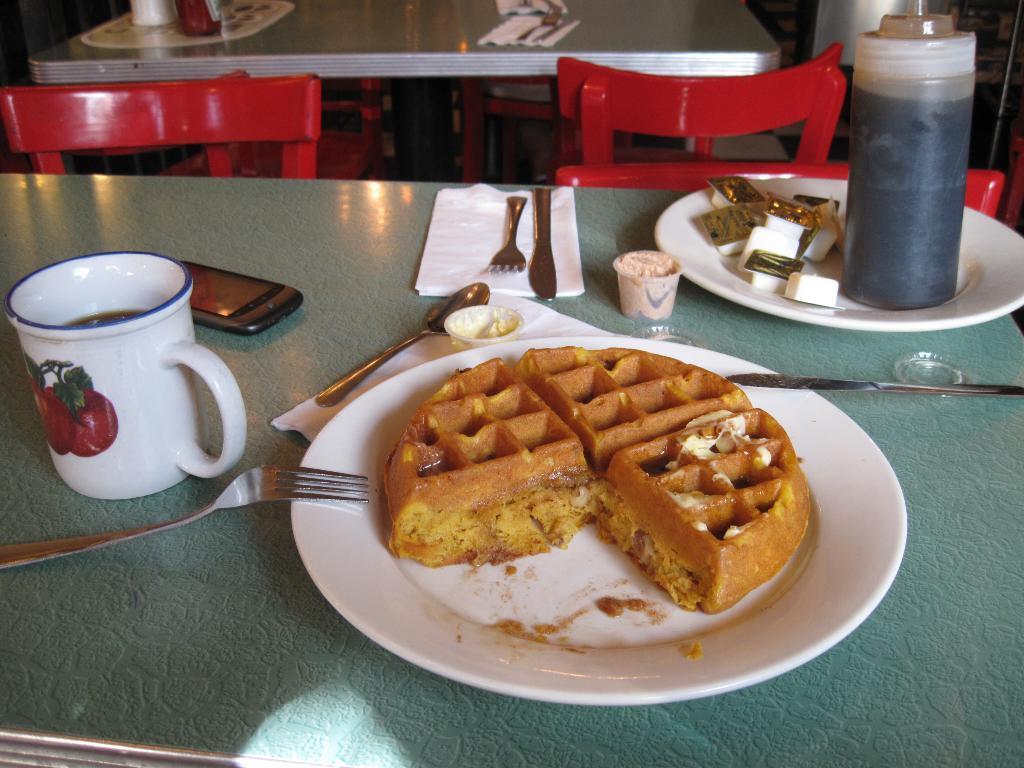Please provide a concise description of this image. In this picture we can see the platform, on this platform we can see a mobile, plates, cup, bottle, spoon, forks, knives, food, tissue papers and in the background we can see a table, chairs and some objects. 